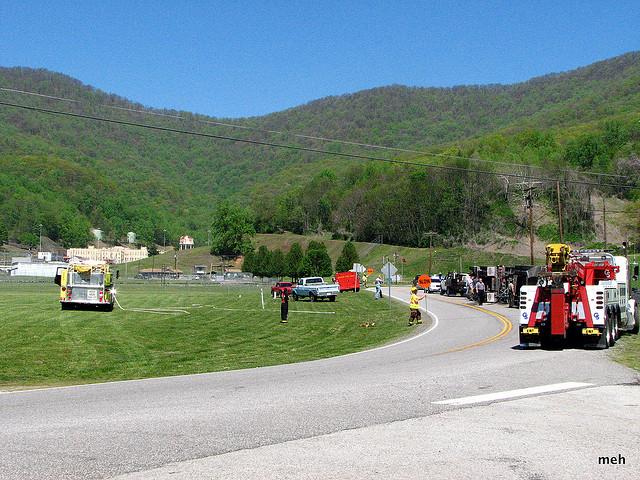Are these hills or mountains?
Be succinct. Hills. Are these racers on a track?
Quick response, please. No. What does the orange sign say?
Short answer required. Slow. Are there animals in the forest?
Keep it brief. No. How many fire trucks are in this photo?
Concise answer only. 1. 